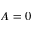Convert formula to latex. <formula><loc_0><loc_0><loc_500><loc_500>A = 0</formula> 